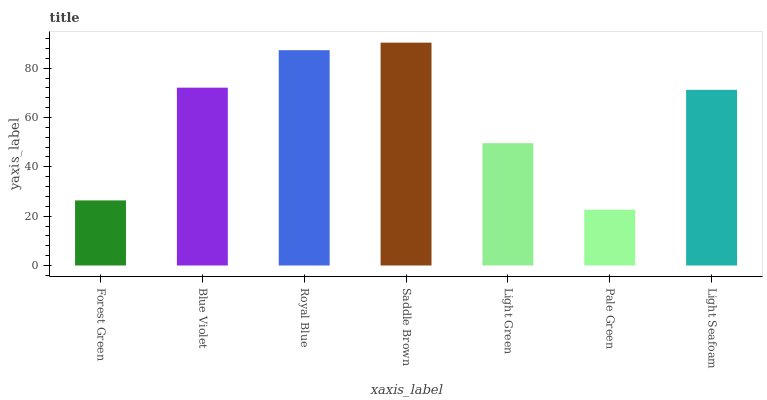Is Pale Green the minimum?
Answer yes or no. Yes. Is Saddle Brown the maximum?
Answer yes or no. Yes. Is Blue Violet the minimum?
Answer yes or no. No. Is Blue Violet the maximum?
Answer yes or no. No. Is Blue Violet greater than Forest Green?
Answer yes or no. Yes. Is Forest Green less than Blue Violet?
Answer yes or no. Yes. Is Forest Green greater than Blue Violet?
Answer yes or no. No. Is Blue Violet less than Forest Green?
Answer yes or no. No. Is Light Seafoam the high median?
Answer yes or no. Yes. Is Light Seafoam the low median?
Answer yes or no. Yes. Is Forest Green the high median?
Answer yes or no. No. Is Light Green the low median?
Answer yes or no. No. 